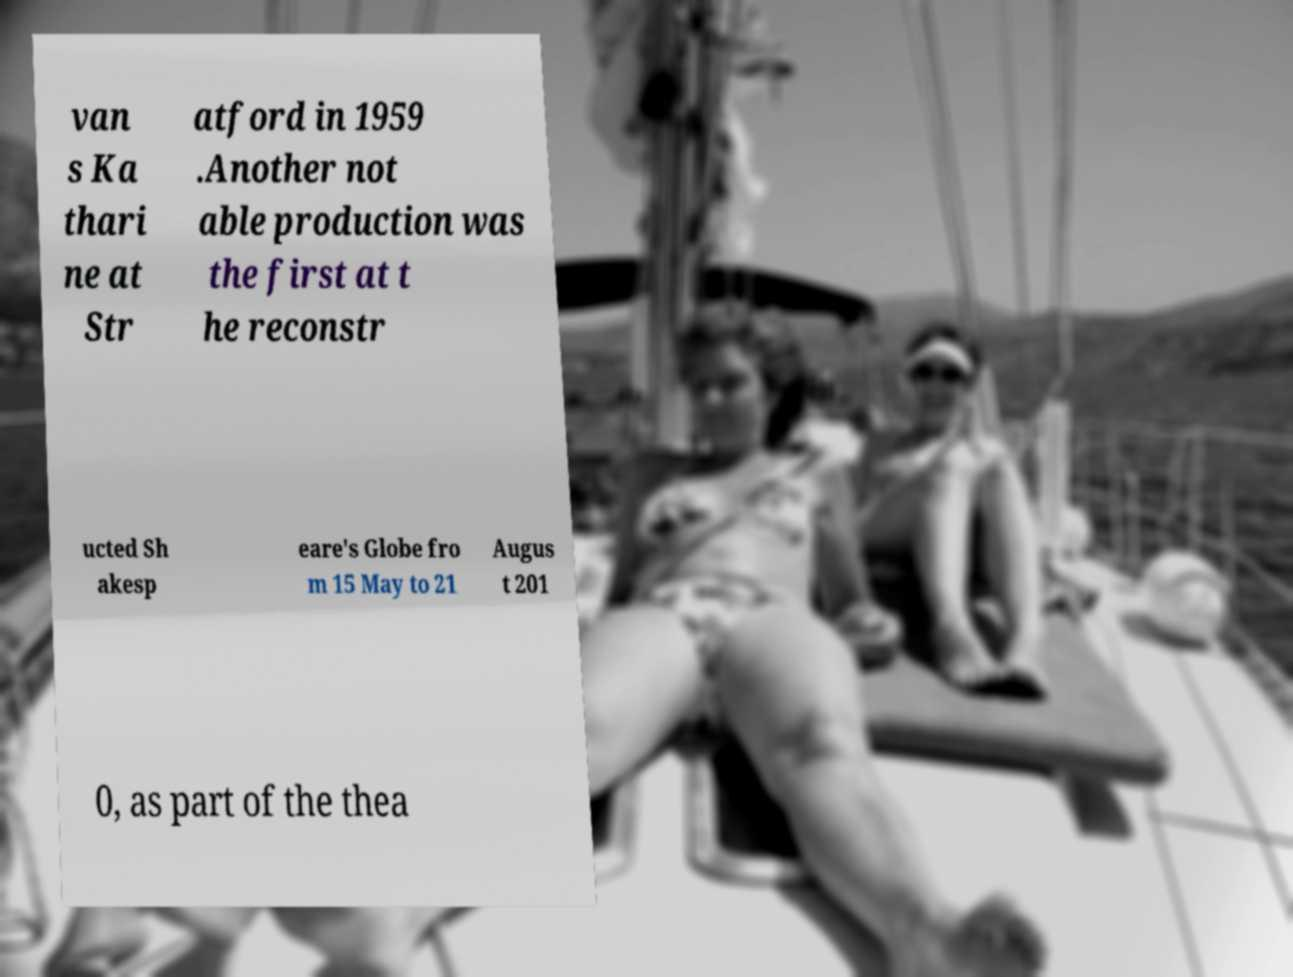For documentation purposes, I need the text within this image transcribed. Could you provide that? van s Ka thari ne at Str atford in 1959 .Another not able production was the first at t he reconstr ucted Sh akesp eare's Globe fro m 15 May to 21 Augus t 201 0, as part of the thea 